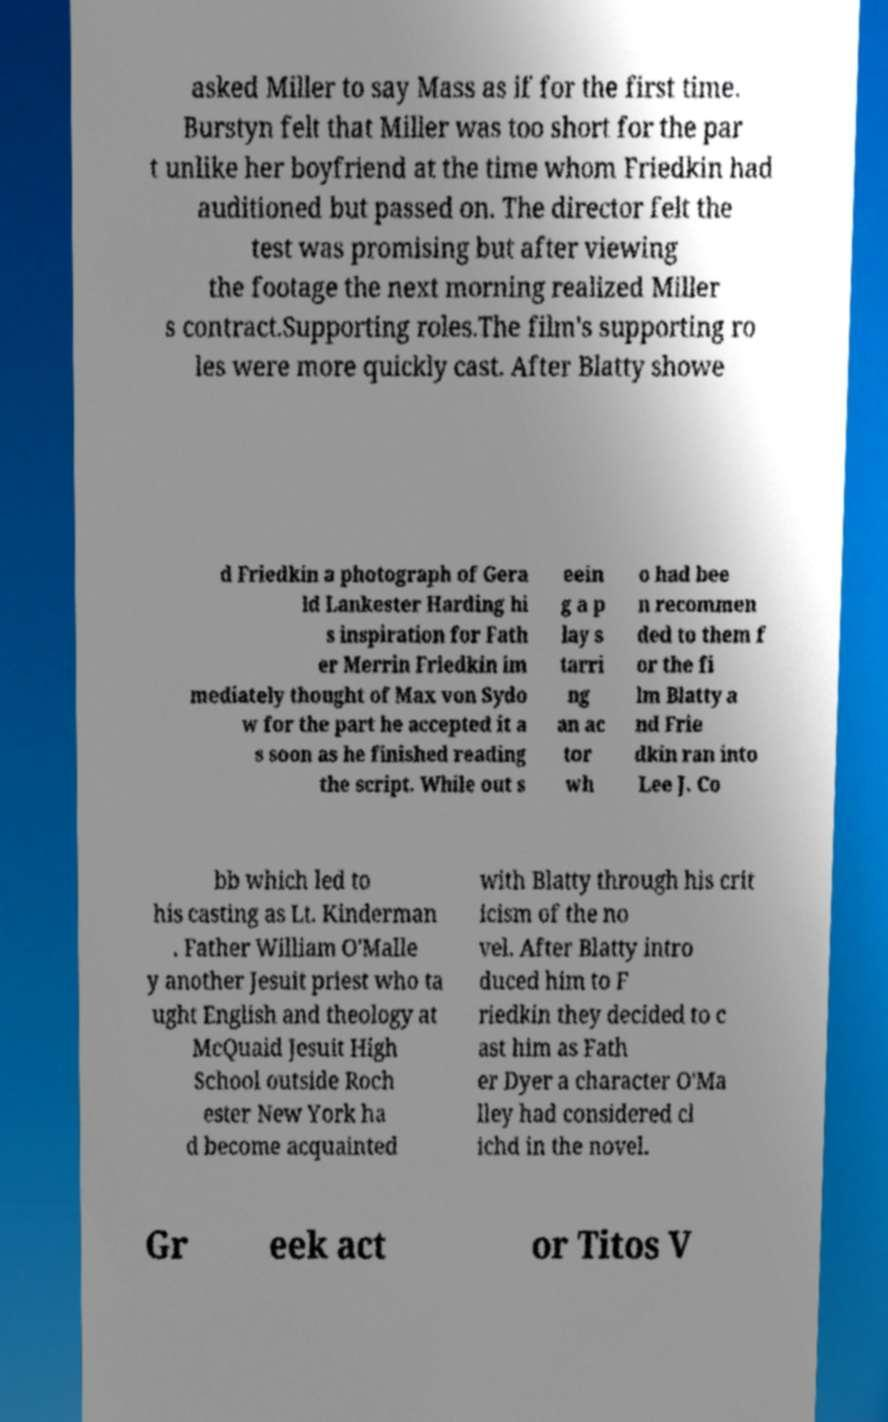Please read and relay the text visible in this image. What does it say? asked Miller to say Mass as if for the first time. Burstyn felt that Miller was too short for the par t unlike her boyfriend at the time whom Friedkin had auditioned but passed on. The director felt the test was promising but after viewing the footage the next morning realized Miller s contract.Supporting roles.The film's supporting ro les were more quickly cast. After Blatty showe d Friedkin a photograph of Gera ld Lankester Harding hi s inspiration for Fath er Merrin Friedkin im mediately thought of Max von Sydo w for the part he accepted it a s soon as he finished reading the script. While out s eein g a p lay s tarri ng an ac tor wh o had bee n recommen ded to them f or the fi lm Blatty a nd Frie dkin ran into Lee J. Co bb which led to his casting as Lt. Kinderman . Father William O'Malle y another Jesuit priest who ta ught English and theology at McQuaid Jesuit High School outside Roch ester New York ha d become acquainted with Blatty through his crit icism of the no vel. After Blatty intro duced him to F riedkin they decided to c ast him as Fath er Dyer a character O'Ma lley had considered cl ichd in the novel. Gr eek act or Titos V 